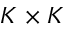Convert formula to latex. <formula><loc_0><loc_0><loc_500><loc_500>K \times K</formula> 